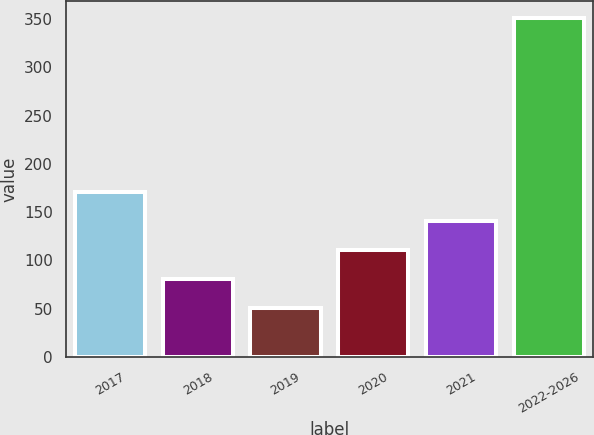<chart> <loc_0><loc_0><loc_500><loc_500><bar_chart><fcel>2017<fcel>2018<fcel>2019<fcel>2020<fcel>2021<fcel>2022-2026<nl><fcel>171<fcel>81<fcel>51<fcel>111<fcel>141<fcel>351<nl></chart> 